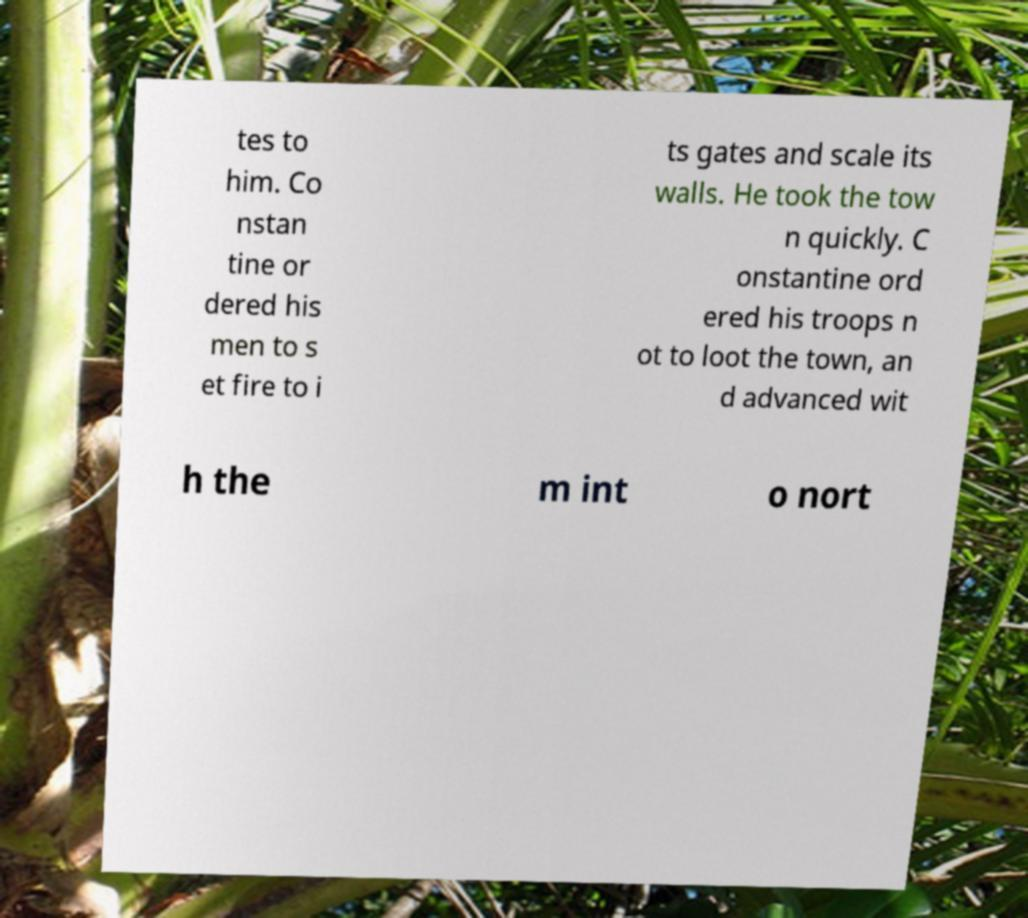Could you extract and type out the text from this image? tes to him. Co nstan tine or dered his men to s et fire to i ts gates and scale its walls. He took the tow n quickly. C onstantine ord ered his troops n ot to loot the town, an d advanced wit h the m int o nort 